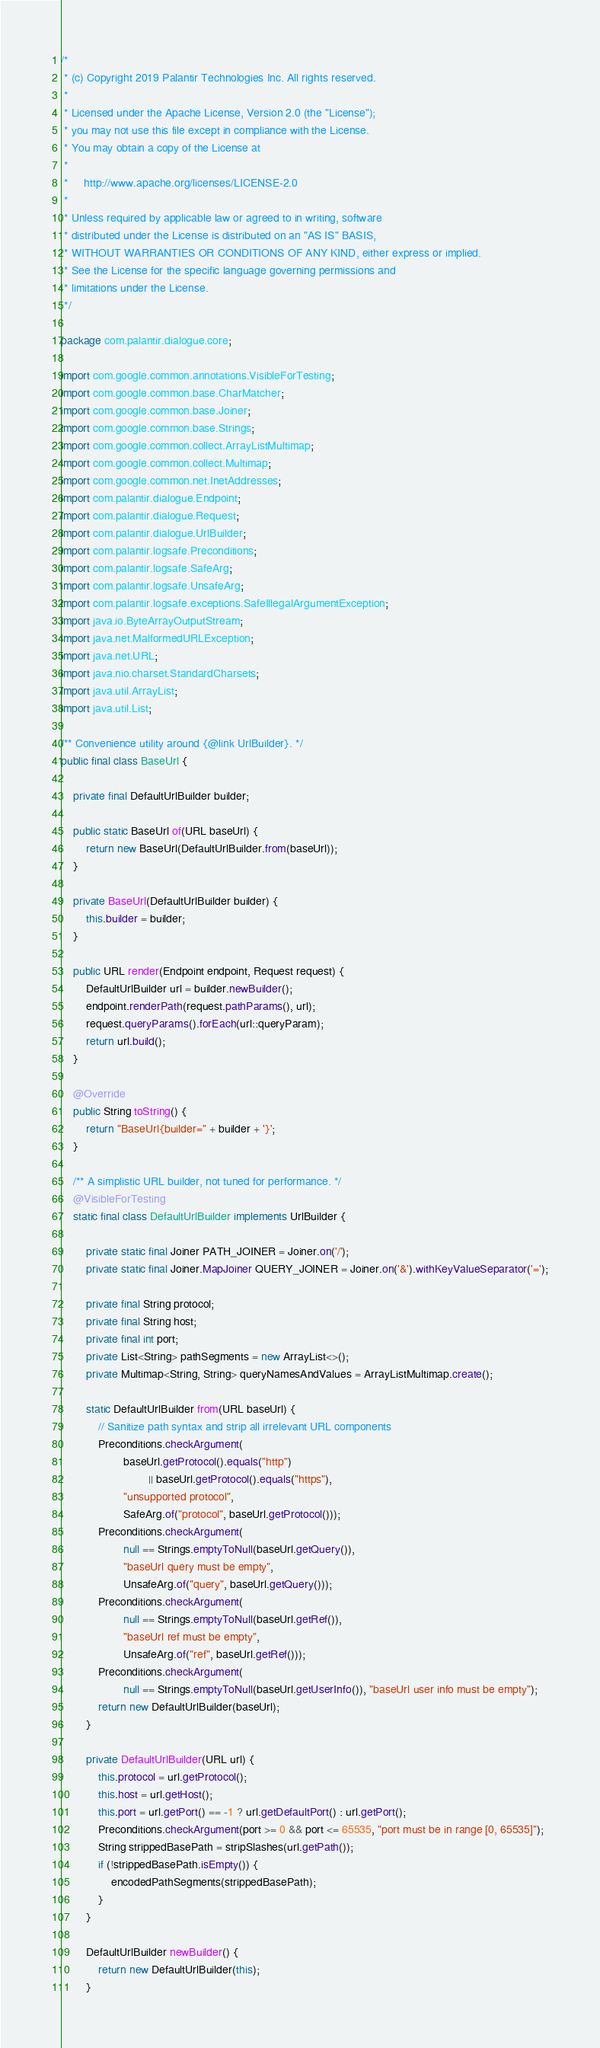<code> <loc_0><loc_0><loc_500><loc_500><_Java_>/*
 * (c) Copyright 2019 Palantir Technologies Inc. All rights reserved.
 *
 * Licensed under the Apache License, Version 2.0 (the "License");
 * you may not use this file except in compliance with the License.
 * You may obtain a copy of the License at
 *
 *     http://www.apache.org/licenses/LICENSE-2.0
 *
 * Unless required by applicable law or agreed to in writing, software
 * distributed under the License is distributed on an "AS IS" BASIS,
 * WITHOUT WARRANTIES OR CONDITIONS OF ANY KIND, either express or implied.
 * See the License for the specific language governing permissions and
 * limitations under the License.
 */

package com.palantir.dialogue.core;

import com.google.common.annotations.VisibleForTesting;
import com.google.common.base.CharMatcher;
import com.google.common.base.Joiner;
import com.google.common.base.Strings;
import com.google.common.collect.ArrayListMultimap;
import com.google.common.collect.Multimap;
import com.google.common.net.InetAddresses;
import com.palantir.dialogue.Endpoint;
import com.palantir.dialogue.Request;
import com.palantir.dialogue.UrlBuilder;
import com.palantir.logsafe.Preconditions;
import com.palantir.logsafe.SafeArg;
import com.palantir.logsafe.UnsafeArg;
import com.palantir.logsafe.exceptions.SafeIllegalArgumentException;
import java.io.ByteArrayOutputStream;
import java.net.MalformedURLException;
import java.net.URL;
import java.nio.charset.StandardCharsets;
import java.util.ArrayList;
import java.util.List;

/** Convenience utility around {@link UrlBuilder}. */
public final class BaseUrl {

    private final DefaultUrlBuilder builder;

    public static BaseUrl of(URL baseUrl) {
        return new BaseUrl(DefaultUrlBuilder.from(baseUrl));
    }

    private BaseUrl(DefaultUrlBuilder builder) {
        this.builder = builder;
    }

    public URL render(Endpoint endpoint, Request request) {
        DefaultUrlBuilder url = builder.newBuilder();
        endpoint.renderPath(request.pathParams(), url);
        request.queryParams().forEach(url::queryParam);
        return url.build();
    }

    @Override
    public String toString() {
        return "BaseUrl{builder=" + builder + '}';
    }

    /** A simplistic URL builder, not tuned for performance. */
    @VisibleForTesting
    static final class DefaultUrlBuilder implements UrlBuilder {

        private static final Joiner PATH_JOINER = Joiner.on('/');
        private static final Joiner.MapJoiner QUERY_JOINER = Joiner.on('&').withKeyValueSeparator('=');

        private final String protocol;
        private final String host;
        private final int port;
        private List<String> pathSegments = new ArrayList<>();
        private Multimap<String, String> queryNamesAndValues = ArrayListMultimap.create();

        static DefaultUrlBuilder from(URL baseUrl) {
            // Sanitize path syntax and strip all irrelevant URL components
            Preconditions.checkArgument(
                    baseUrl.getProtocol().equals("http")
                            || baseUrl.getProtocol().equals("https"),
                    "unsupported protocol",
                    SafeArg.of("protocol", baseUrl.getProtocol()));
            Preconditions.checkArgument(
                    null == Strings.emptyToNull(baseUrl.getQuery()),
                    "baseUrl query must be empty",
                    UnsafeArg.of("query", baseUrl.getQuery()));
            Preconditions.checkArgument(
                    null == Strings.emptyToNull(baseUrl.getRef()),
                    "baseUrl ref must be empty",
                    UnsafeArg.of("ref", baseUrl.getRef()));
            Preconditions.checkArgument(
                    null == Strings.emptyToNull(baseUrl.getUserInfo()), "baseUrl user info must be empty");
            return new DefaultUrlBuilder(baseUrl);
        }

        private DefaultUrlBuilder(URL url) {
            this.protocol = url.getProtocol();
            this.host = url.getHost();
            this.port = url.getPort() == -1 ? url.getDefaultPort() : url.getPort();
            Preconditions.checkArgument(port >= 0 && port <= 65535, "port must be in range [0, 65535]");
            String strippedBasePath = stripSlashes(url.getPath());
            if (!strippedBasePath.isEmpty()) {
                encodedPathSegments(strippedBasePath);
            }
        }

        DefaultUrlBuilder newBuilder() {
            return new DefaultUrlBuilder(this);
        }
</code> 